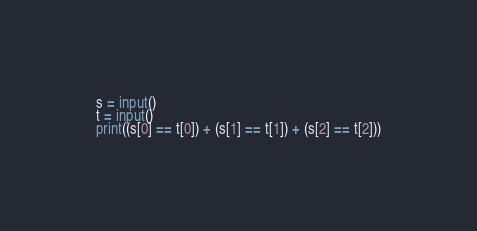Convert code to text. <code><loc_0><loc_0><loc_500><loc_500><_Python_>s = input()
t = input()
print((s[0] == t[0]) + (s[1] == t[1]) + (s[2] == t[2]))</code> 